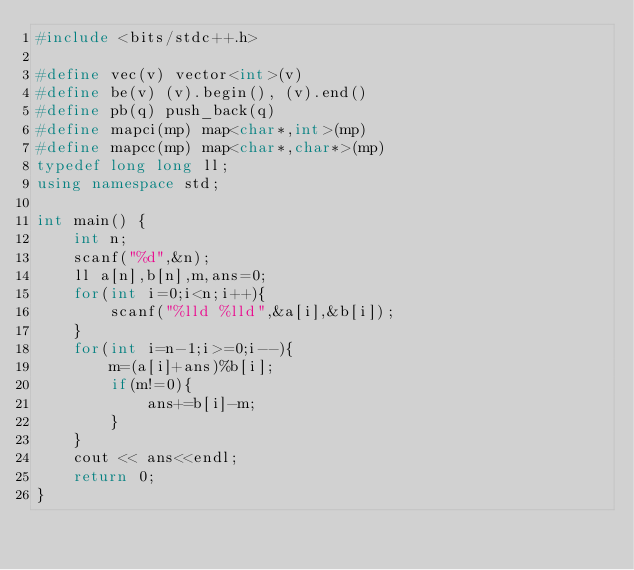Convert code to text. <code><loc_0><loc_0><loc_500><loc_500><_C++_>#include <bits/stdc++.h>

#define vec(v) vector<int>(v)
#define be(v) (v).begin(), (v).end()
#define pb(q) push_back(q)
#define mapci(mp) map<char*,int>(mp)
#define mapcc(mp) map<char*,char*>(mp)
typedef long long ll;
using namespace std;

int main() {
    int n;
    scanf("%d",&n);
    ll a[n],b[n],m,ans=0;
    for(int i=0;i<n;i++){
        scanf("%lld %lld",&a[i],&b[i]);
    }
    for(int i=n-1;i>=0;i--){
        m=(a[i]+ans)%b[i];
        if(m!=0){
            ans+=b[i]-m;
        }
    }
    cout << ans<<endl;
    return 0;
}
</code> 